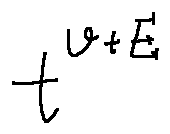Convert formula to latex. <formula><loc_0><loc_0><loc_500><loc_500>t ^ { v + E }</formula> 